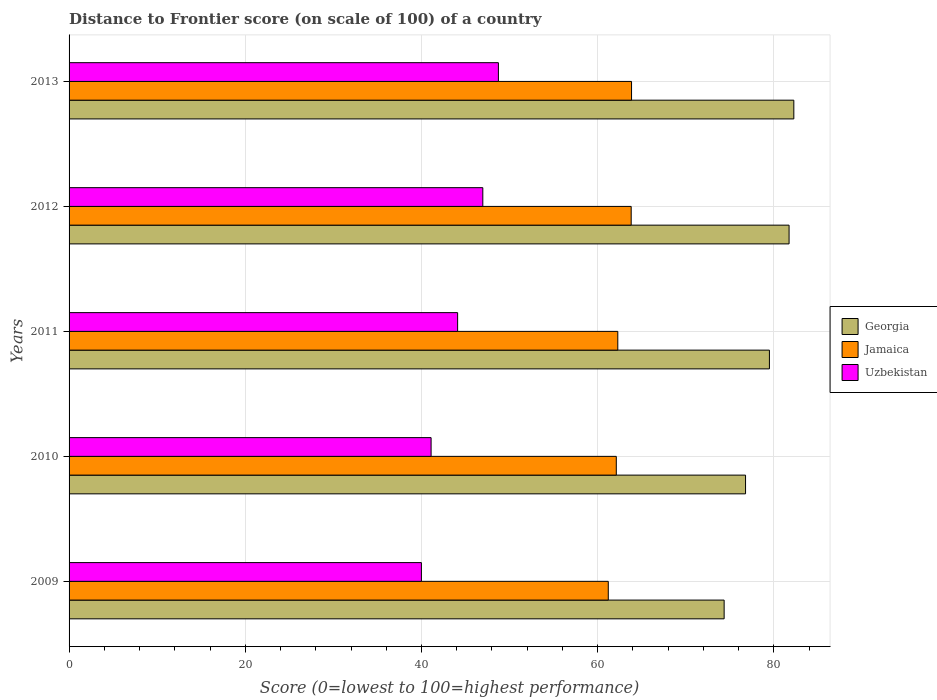How many different coloured bars are there?
Your response must be concise. 3. How many groups of bars are there?
Provide a short and direct response. 5. Are the number of bars per tick equal to the number of legend labels?
Offer a very short reply. Yes. Are the number of bars on each tick of the Y-axis equal?
Keep it short and to the point. Yes. In how many cases, is the number of bars for a given year not equal to the number of legend labels?
Offer a terse response. 0. What is the distance to frontier score of in Georgia in 2010?
Provide a succinct answer. 76.78. Across all years, what is the maximum distance to frontier score of in Georgia?
Provide a succinct answer. 82.26. Across all years, what is the minimum distance to frontier score of in Jamaica?
Offer a very short reply. 61.2. In which year was the distance to frontier score of in Jamaica maximum?
Provide a succinct answer. 2013. What is the total distance to frontier score of in Uzbekistan in the graph?
Offer a terse response. 220.87. What is the difference between the distance to frontier score of in Jamaica in 2009 and that in 2012?
Your response must be concise. -2.6. What is the difference between the distance to frontier score of in Uzbekistan in 2010 and the distance to frontier score of in Georgia in 2009?
Your response must be concise. -33.26. What is the average distance to frontier score of in Jamaica per year?
Ensure brevity in your answer.  62.65. In the year 2009, what is the difference between the distance to frontier score of in Uzbekistan and distance to frontier score of in Jamaica?
Provide a short and direct response. -21.21. What is the ratio of the distance to frontier score of in Georgia in 2009 to that in 2012?
Offer a terse response. 0.91. Is the distance to frontier score of in Georgia in 2010 less than that in 2012?
Ensure brevity in your answer.  Yes. Is the difference between the distance to frontier score of in Uzbekistan in 2010 and 2012 greater than the difference between the distance to frontier score of in Jamaica in 2010 and 2012?
Your response must be concise. No. What is the difference between the highest and the second highest distance to frontier score of in Jamaica?
Give a very brief answer. 0.04. What is the difference between the highest and the lowest distance to frontier score of in Georgia?
Make the answer very short. 7.91. What does the 2nd bar from the top in 2013 represents?
Offer a very short reply. Jamaica. What does the 2nd bar from the bottom in 2013 represents?
Provide a short and direct response. Jamaica. Is it the case that in every year, the sum of the distance to frontier score of in Georgia and distance to frontier score of in Uzbekistan is greater than the distance to frontier score of in Jamaica?
Provide a short and direct response. Yes. Are all the bars in the graph horizontal?
Give a very brief answer. Yes. What is the difference between two consecutive major ticks on the X-axis?
Offer a very short reply. 20. Are the values on the major ticks of X-axis written in scientific E-notation?
Give a very brief answer. No. Where does the legend appear in the graph?
Make the answer very short. Center right. What is the title of the graph?
Offer a terse response. Distance to Frontier score (on scale of 100) of a country. What is the label or title of the X-axis?
Make the answer very short. Score (0=lowest to 100=highest performance). What is the Score (0=lowest to 100=highest performance) of Georgia in 2009?
Your answer should be compact. 74.35. What is the Score (0=lowest to 100=highest performance) of Jamaica in 2009?
Your answer should be compact. 61.2. What is the Score (0=lowest to 100=highest performance) of Uzbekistan in 2009?
Your answer should be very brief. 39.99. What is the Score (0=lowest to 100=highest performance) of Georgia in 2010?
Your answer should be very brief. 76.78. What is the Score (0=lowest to 100=highest performance) in Jamaica in 2010?
Keep it short and to the point. 62.11. What is the Score (0=lowest to 100=highest performance) of Uzbekistan in 2010?
Your response must be concise. 41.09. What is the Score (0=lowest to 100=highest performance) of Georgia in 2011?
Your answer should be very brief. 79.49. What is the Score (0=lowest to 100=highest performance) of Jamaica in 2011?
Your answer should be compact. 62.28. What is the Score (0=lowest to 100=highest performance) in Uzbekistan in 2011?
Offer a terse response. 44.1. What is the Score (0=lowest to 100=highest performance) in Georgia in 2012?
Ensure brevity in your answer.  81.72. What is the Score (0=lowest to 100=highest performance) in Jamaica in 2012?
Provide a succinct answer. 63.8. What is the Score (0=lowest to 100=highest performance) of Uzbekistan in 2012?
Provide a short and direct response. 46.96. What is the Score (0=lowest to 100=highest performance) in Georgia in 2013?
Offer a terse response. 82.26. What is the Score (0=lowest to 100=highest performance) of Jamaica in 2013?
Offer a terse response. 63.84. What is the Score (0=lowest to 100=highest performance) in Uzbekistan in 2013?
Provide a succinct answer. 48.73. Across all years, what is the maximum Score (0=lowest to 100=highest performance) of Georgia?
Ensure brevity in your answer.  82.26. Across all years, what is the maximum Score (0=lowest to 100=highest performance) in Jamaica?
Give a very brief answer. 63.84. Across all years, what is the maximum Score (0=lowest to 100=highest performance) of Uzbekistan?
Provide a short and direct response. 48.73. Across all years, what is the minimum Score (0=lowest to 100=highest performance) of Georgia?
Your answer should be very brief. 74.35. Across all years, what is the minimum Score (0=lowest to 100=highest performance) in Jamaica?
Ensure brevity in your answer.  61.2. Across all years, what is the minimum Score (0=lowest to 100=highest performance) in Uzbekistan?
Offer a very short reply. 39.99. What is the total Score (0=lowest to 100=highest performance) of Georgia in the graph?
Give a very brief answer. 394.6. What is the total Score (0=lowest to 100=highest performance) of Jamaica in the graph?
Your answer should be very brief. 313.23. What is the total Score (0=lowest to 100=highest performance) in Uzbekistan in the graph?
Give a very brief answer. 220.87. What is the difference between the Score (0=lowest to 100=highest performance) of Georgia in 2009 and that in 2010?
Your answer should be very brief. -2.43. What is the difference between the Score (0=lowest to 100=highest performance) in Jamaica in 2009 and that in 2010?
Ensure brevity in your answer.  -0.91. What is the difference between the Score (0=lowest to 100=highest performance) in Georgia in 2009 and that in 2011?
Give a very brief answer. -5.14. What is the difference between the Score (0=lowest to 100=highest performance) in Jamaica in 2009 and that in 2011?
Offer a terse response. -1.08. What is the difference between the Score (0=lowest to 100=highest performance) of Uzbekistan in 2009 and that in 2011?
Offer a terse response. -4.11. What is the difference between the Score (0=lowest to 100=highest performance) in Georgia in 2009 and that in 2012?
Give a very brief answer. -7.37. What is the difference between the Score (0=lowest to 100=highest performance) in Uzbekistan in 2009 and that in 2012?
Make the answer very short. -6.97. What is the difference between the Score (0=lowest to 100=highest performance) in Georgia in 2009 and that in 2013?
Keep it short and to the point. -7.91. What is the difference between the Score (0=lowest to 100=highest performance) in Jamaica in 2009 and that in 2013?
Your answer should be compact. -2.64. What is the difference between the Score (0=lowest to 100=highest performance) of Uzbekistan in 2009 and that in 2013?
Your response must be concise. -8.74. What is the difference between the Score (0=lowest to 100=highest performance) in Georgia in 2010 and that in 2011?
Offer a terse response. -2.71. What is the difference between the Score (0=lowest to 100=highest performance) of Jamaica in 2010 and that in 2011?
Provide a succinct answer. -0.17. What is the difference between the Score (0=lowest to 100=highest performance) of Uzbekistan in 2010 and that in 2011?
Offer a terse response. -3.01. What is the difference between the Score (0=lowest to 100=highest performance) in Georgia in 2010 and that in 2012?
Ensure brevity in your answer.  -4.94. What is the difference between the Score (0=lowest to 100=highest performance) in Jamaica in 2010 and that in 2012?
Offer a terse response. -1.69. What is the difference between the Score (0=lowest to 100=highest performance) of Uzbekistan in 2010 and that in 2012?
Your response must be concise. -5.87. What is the difference between the Score (0=lowest to 100=highest performance) of Georgia in 2010 and that in 2013?
Ensure brevity in your answer.  -5.48. What is the difference between the Score (0=lowest to 100=highest performance) in Jamaica in 2010 and that in 2013?
Your response must be concise. -1.73. What is the difference between the Score (0=lowest to 100=highest performance) of Uzbekistan in 2010 and that in 2013?
Ensure brevity in your answer.  -7.64. What is the difference between the Score (0=lowest to 100=highest performance) of Georgia in 2011 and that in 2012?
Make the answer very short. -2.23. What is the difference between the Score (0=lowest to 100=highest performance) in Jamaica in 2011 and that in 2012?
Offer a very short reply. -1.52. What is the difference between the Score (0=lowest to 100=highest performance) in Uzbekistan in 2011 and that in 2012?
Offer a very short reply. -2.86. What is the difference between the Score (0=lowest to 100=highest performance) of Georgia in 2011 and that in 2013?
Offer a terse response. -2.77. What is the difference between the Score (0=lowest to 100=highest performance) in Jamaica in 2011 and that in 2013?
Your answer should be very brief. -1.56. What is the difference between the Score (0=lowest to 100=highest performance) of Uzbekistan in 2011 and that in 2013?
Ensure brevity in your answer.  -4.63. What is the difference between the Score (0=lowest to 100=highest performance) of Georgia in 2012 and that in 2013?
Make the answer very short. -0.54. What is the difference between the Score (0=lowest to 100=highest performance) in Jamaica in 2012 and that in 2013?
Your answer should be very brief. -0.04. What is the difference between the Score (0=lowest to 100=highest performance) of Uzbekistan in 2012 and that in 2013?
Make the answer very short. -1.77. What is the difference between the Score (0=lowest to 100=highest performance) of Georgia in 2009 and the Score (0=lowest to 100=highest performance) of Jamaica in 2010?
Offer a very short reply. 12.24. What is the difference between the Score (0=lowest to 100=highest performance) of Georgia in 2009 and the Score (0=lowest to 100=highest performance) of Uzbekistan in 2010?
Give a very brief answer. 33.26. What is the difference between the Score (0=lowest to 100=highest performance) in Jamaica in 2009 and the Score (0=lowest to 100=highest performance) in Uzbekistan in 2010?
Provide a succinct answer. 20.11. What is the difference between the Score (0=lowest to 100=highest performance) of Georgia in 2009 and the Score (0=lowest to 100=highest performance) of Jamaica in 2011?
Make the answer very short. 12.07. What is the difference between the Score (0=lowest to 100=highest performance) of Georgia in 2009 and the Score (0=lowest to 100=highest performance) of Uzbekistan in 2011?
Your response must be concise. 30.25. What is the difference between the Score (0=lowest to 100=highest performance) of Georgia in 2009 and the Score (0=lowest to 100=highest performance) of Jamaica in 2012?
Offer a very short reply. 10.55. What is the difference between the Score (0=lowest to 100=highest performance) of Georgia in 2009 and the Score (0=lowest to 100=highest performance) of Uzbekistan in 2012?
Offer a terse response. 27.39. What is the difference between the Score (0=lowest to 100=highest performance) in Jamaica in 2009 and the Score (0=lowest to 100=highest performance) in Uzbekistan in 2012?
Offer a very short reply. 14.24. What is the difference between the Score (0=lowest to 100=highest performance) of Georgia in 2009 and the Score (0=lowest to 100=highest performance) of Jamaica in 2013?
Keep it short and to the point. 10.51. What is the difference between the Score (0=lowest to 100=highest performance) in Georgia in 2009 and the Score (0=lowest to 100=highest performance) in Uzbekistan in 2013?
Provide a short and direct response. 25.62. What is the difference between the Score (0=lowest to 100=highest performance) of Jamaica in 2009 and the Score (0=lowest to 100=highest performance) of Uzbekistan in 2013?
Provide a succinct answer. 12.47. What is the difference between the Score (0=lowest to 100=highest performance) of Georgia in 2010 and the Score (0=lowest to 100=highest performance) of Uzbekistan in 2011?
Your answer should be compact. 32.68. What is the difference between the Score (0=lowest to 100=highest performance) in Jamaica in 2010 and the Score (0=lowest to 100=highest performance) in Uzbekistan in 2011?
Your response must be concise. 18.01. What is the difference between the Score (0=lowest to 100=highest performance) in Georgia in 2010 and the Score (0=lowest to 100=highest performance) in Jamaica in 2012?
Offer a terse response. 12.98. What is the difference between the Score (0=lowest to 100=highest performance) in Georgia in 2010 and the Score (0=lowest to 100=highest performance) in Uzbekistan in 2012?
Keep it short and to the point. 29.82. What is the difference between the Score (0=lowest to 100=highest performance) of Jamaica in 2010 and the Score (0=lowest to 100=highest performance) of Uzbekistan in 2012?
Offer a terse response. 15.15. What is the difference between the Score (0=lowest to 100=highest performance) of Georgia in 2010 and the Score (0=lowest to 100=highest performance) of Jamaica in 2013?
Ensure brevity in your answer.  12.94. What is the difference between the Score (0=lowest to 100=highest performance) in Georgia in 2010 and the Score (0=lowest to 100=highest performance) in Uzbekistan in 2013?
Give a very brief answer. 28.05. What is the difference between the Score (0=lowest to 100=highest performance) in Jamaica in 2010 and the Score (0=lowest to 100=highest performance) in Uzbekistan in 2013?
Ensure brevity in your answer.  13.38. What is the difference between the Score (0=lowest to 100=highest performance) of Georgia in 2011 and the Score (0=lowest to 100=highest performance) of Jamaica in 2012?
Make the answer very short. 15.69. What is the difference between the Score (0=lowest to 100=highest performance) of Georgia in 2011 and the Score (0=lowest to 100=highest performance) of Uzbekistan in 2012?
Ensure brevity in your answer.  32.53. What is the difference between the Score (0=lowest to 100=highest performance) of Jamaica in 2011 and the Score (0=lowest to 100=highest performance) of Uzbekistan in 2012?
Your response must be concise. 15.32. What is the difference between the Score (0=lowest to 100=highest performance) of Georgia in 2011 and the Score (0=lowest to 100=highest performance) of Jamaica in 2013?
Your response must be concise. 15.65. What is the difference between the Score (0=lowest to 100=highest performance) of Georgia in 2011 and the Score (0=lowest to 100=highest performance) of Uzbekistan in 2013?
Your answer should be very brief. 30.76. What is the difference between the Score (0=lowest to 100=highest performance) of Jamaica in 2011 and the Score (0=lowest to 100=highest performance) of Uzbekistan in 2013?
Make the answer very short. 13.55. What is the difference between the Score (0=lowest to 100=highest performance) in Georgia in 2012 and the Score (0=lowest to 100=highest performance) in Jamaica in 2013?
Offer a very short reply. 17.88. What is the difference between the Score (0=lowest to 100=highest performance) in Georgia in 2012 and the Score (0=lowest to 100=highest performance) in Uzbekistan in 2013?
Provide a succinct answer. 32.99. What is the difference between the Score (0=lowest to 100=highest performance) in Jamaica in 2012 and the Score (0=lowest to 100=highest performance) in Uzbekistan in 2013?
Provide a succinct answer. 15.07. What is the average Score (0=lowest to 100=highest performance) in Georgia per year?
Give a very brief answer. 78.92. What is the average Score (0=lowest to 100=highest performance) of Jamaica per year?
Provide a succinct answer. 62.65. What is the average Score (0=lowest to 100=highest performance) of Uzbekistan per year?
Provide a succinct answer. 44.17. In the year 2009, what is the difference between the Score (0=lowest to 100=highest performance) of Georgia and Score (0=lowest to 100=highest performance) of Jamaica?
Offer a terse response. 13.15. In the year 2009, what is the difference between the Score (0=lowest to 100=highest performance) of Georgia and Score (0=lowest to 100=highest performance) of Uzbekistan?
Your answer should be very brief. 34.36. In the year 2009, what is the difference between the Score (0=lowest to 100=highest performance) in Jamaica and Score (0=lowest to 100=highest performance) in Uzbekistan?
Provide a short and direct response. 21.21. In the year 2010, what is the difference between the Score (0=lowest to 100=highest performance) of Georgia and Score (0=lowest to 100=highest performance) of Jamaica?
Provide a succinct answer. 14.67. In the year 2010, what is the difference between the Score (0=lowest to 100=highest performance) in Georgia and Score (0=lowest to 100=highest performance) in Uzbekistan?
Your answer should be very brief. 35.69. In the year 2010, what is the difference between the Score (0=lowest to 100=highest performance) in Jamaica and Score (0=lowest to 100=highest performance) in Uzbekistan?
Your answer should be compact. 21.02. In the year 2011, what is the difference between the Score (0=lowest to 100=highest performance) in Georgia and Score (0=lowest to 100=highest performance) in Jamaica?
Provide a short and direct response. 17.21. In the year 2011, what is the difference between the Score (0=lowest to 100=highest performance) of Georgia and Score (0=lowest to 100=highest performance) of Uzbekistan?
Give a very brief answer. 35.39. In the year 2011, what is the difference between the Score (0=lowest to 100=highest performance) of Jamaica and Score (0=lowest to 100=highest performance) of Uzbekistan?
Offer a very short reply. 18.18. In the year 2012, what is the difference between the Score (0=lowest to 100=highest performance) in Georgia and Score (0=lowest to 100=highest performance) in Jamaica?
Offer a very short reply. 17.92. In the year 2012, what is the difference between the Score (0=lowest to 100=highest performance) of Georgia and Score (0=lowest to 100=highest performance) of Uzbekistan?
Keep it short and to the point. 34.76. In the year 2012, what is the difference between the Score (0=lowest to 100=highest performance) of Jamaica and Score (0=lowest to 100=highest performance) of Uzbekistan?
Provide a short and direct response. 16.84. In the year 2013, what is the difference between the Score (0=lowest to 100=highest performance) of Georgia and Score (0=lowest to 100=highest performance) of Jamaica?
Provide a short and direct response. 18.42. In the year 2013, what is the difference between the Score (0=lowest to 100=highest performance) in Georgia and Score (0=lowest to 100=highest performance) in Uzbekistan?
Ensure brevity in your answer.  33.53. In the year 2013, what is the difference between the Score (0=lowest to 100=highest performance) of Jamaica and Score (0=lowest to 100=highest performance) of Uzbekistan?
Make the answer very short. 15.11. What is the ratio of the Score (0=lowest to 100=highest performance) of Georgia in 2009 to that in 2010?
Your response must be concise. 0.97. What is the ratio of the Score (0=lowest to 100=highest performance) in Jamaica in 2009 to that in 2010?
Keep it short and to the point. 0.99. What is the ratio of the Score (0=lowest to 100=highest performance) in Uzbekistan in 2009 to that in 2010?
Your answer should be very brief. 0.97. What is the ratio of the Score (0=lowest to 100=highest performance) in Georgia in 2009 to that in 2011?
Offer a terse response. 0.94. What is the ratio of the Score (0=lowest to 100=highest performance) in Jamaica in 2009 to that in 2011?
Keep it short and to the point. 0.98. What is the ratio of the Score (0=lowest to 100=highest performance) of Uzbekistan in 2009 to that in 2011?
Your answer should be compact. 0.91. What is the ratio of the Score (0=lowest to 100=highest performance) of Georgia in 2009 to that in 2012?
Your answer should be compact. 0.91. What is the ratio of the Score (0=lowest to 100=highest performance) of Jamaica in 2009 to that in 2012?
Offer a very short reply. 0.96. What is the ratio of the Score (0=lowest to 100=highest performance) in Uzbekistan in 2009 to that in 2012?
Your answer should be very brief. 0.85. What is the ratio of the Score (0=lowest to 100=highest performance) of Georgia in 2009 to that in 2013?
Give a very brief answer. 0.9. What is the ratio of the Score (0=lowest to 100=highest performance) of Jamaica in 2009 to that in 2013?
Offer a very short reply. 0.96. What is the ratio of the Score (0=lowest to 100=highest performance) in Uzbekistan in 2009 to that in 2013?
Make the answer very short. 0.82. What is the ratio of the Score (0=lowest to 100=highest performance) in Georgia in 2010 to that in 2011?
Make the answer very short. 0.97. What is the ratio of the Score (0=lowest to 100=highest performance) in Jamaica in 2010 to that in 2011?
Keep it short and to the point. 1. What is the ratio of the Score (0=lowest to 100=highest performance) in Uzbekistan in 2010 to that in 2011?
Your answer should be compact. 0.93. What is the ratio of the Score (0=lowest to 100=highest performance) of Georgia in 2010 to that in 2012?
Provide a short and direct response. 0.94. What is the ratio of the Score (0=lowest to 100=highest performance) in Jamaica in 2010 to that in 2012?
Your answer should be compact. 0.97. What is the ratio of the Score (0=lowest to 100=highest performance) in Uzbekistan in 2010 to that in 2012?
Provide a short and direct response. 0.88. What is the ratio of the Score (0=lowest to 100=highest performance) of Georgia in 2010 to that in 2013?
Your answer should be compact. 0.93. What is the ratio of the Score (0=lowest to 100=highest performance) in Jamaica in 2010 to that in 2013?
Offer a very short reply. 0.97. What is the ratio of the Score (0=lowest to 100=highest performance) of Uzbekistan in 2010 to that in 2013?
Your response must be concise. 0.84. What is the ratio of the Score (0=lowest to 100=highest performance) of Georgia in 2011 to that in 2012?
Ensure brevity in your answer.  0.97. What is the ratio of the Score (0=lowest to 100=highest performance) in Jamaica in 2011 to that in 2012?
Provide a short and direct response. 0.98. What is the ratio of the Score (0=lowest to 100=highest performance) of Uzbekistan in 2011 to that in 2012?
Provide a short and direct response. 0.94. What is the ratio of the Score (0=lowest to 100=highest performance) in Georgia in 2011 to that in 2013?
Your answer should be very brief. 0.97. What is the ratio of the Score (0=lowest to 100=highest performance) in Jamaica in 2011 to that in 2013?
Provide a succinct answer. 0.98. What is the ratio of the Score (0=lowest to 100=highest performance) in Uzbekistan in 2011 to that in 2013?
Provide a succinct answer. 0.91. What is the ratio of the Score (0=lowest to 100=highest performance) in Georgia in 2012 to that in 2013?
Offer a very short reply. 0.99. What is the ratio of the Score (0=lowest to 100=highest performance) in Jamaica in 2012 to that in 2013?
Your response must be concise. 1. What is the ratio of the Score (0=lowest to 100=highest performance) of Uzbekistan in 2012 to that in 2013?
Provide a succinct answer. 0.96. What is the difference between the highest and the second highest Score (0=lowest to 100=highest performance) of Georgia?
Provide a short and direct response. 0.54. What is the difference between the highest and the second highest Score (0=lowest to 100=highest performance) of Uzbekistan?
Provide a short and direct response. 1.77. What is the difference between the highest and the lowest Score (0=lowest to 100=highest performance) of Georgia?
Make the answer very short. 7.91. What is the difference between the highest and the lowest Score (0=lowest to 100=highest performance) in Jamaica?
Your answer should be compact. 2.64. What is the difference between the highest and the lowest Score (0=lowest to 100=highest performance) of Uzbekistan?
Ensure brevity in your answer.  8.74. 